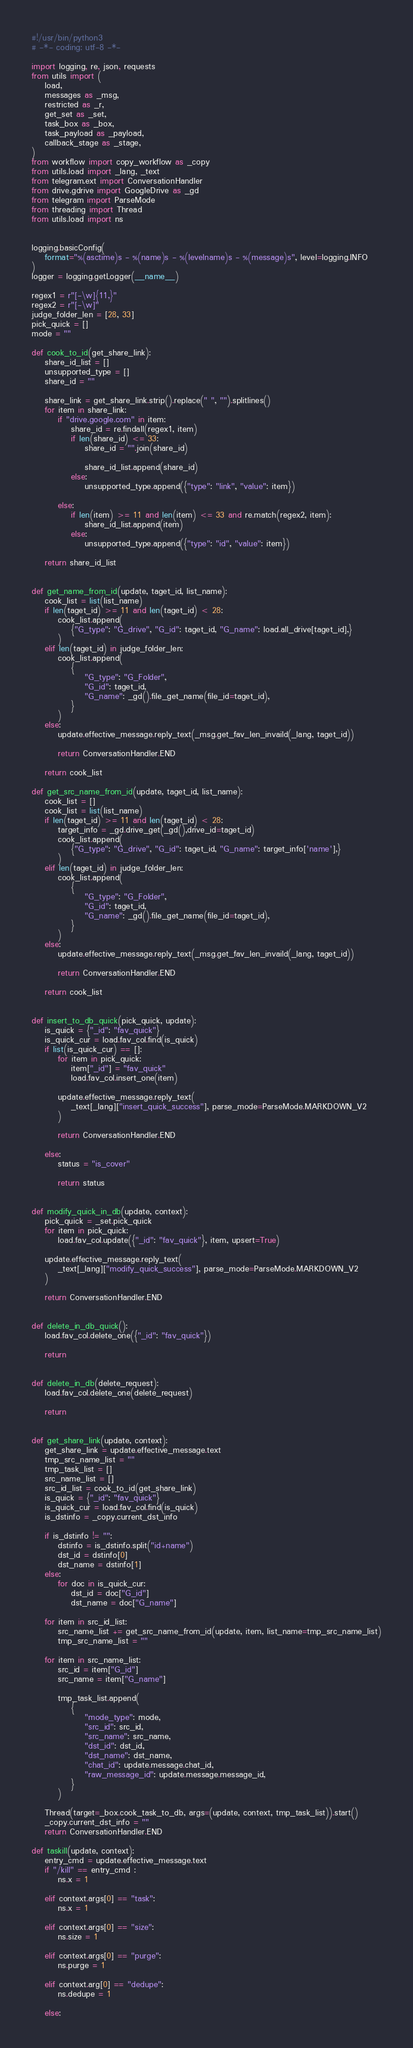Convert code to text. <code><loc_0><loc_0><loc_500><loc_500><_Python_>#!/usr/bin/python3
# -*- coding: utf-8 -*-

import logging, re, json, requests
from utils import (
    load,
    messages as _msg,
    restricted as _r,
    get_set as _set,
    task_box as _box,
    task_payload as _payload,
    callback_stage as _stage,
)
from workflow import copy_workflow as _copy
from utils.load import _lang, _text
from telegram.ext import ConversationHandler
from drive.gdrive import GoogleDrive as _gd
from telegram import ParseMode
from threading import Thread
from utils.load import ns


logging.basicConfig(
    format="%(asctime)s - %(name)s - %(levelname)s - %(message)s", level=logging.INFO
)
logger = logging.getLogger(__name__)

regex1 = r"[-\w]{11,}"
regex2 = r"[-\w]"
judge_folder_len = [28, 33]
pick_quick = []
mode = ""

def cook_to_id(get_share_link):
    share_id_list = []
    unsupported_type = []
    share_id = ""

    share_link = get_share_link.strip().replace(" ", "").splitlines()
    for item in share_link:
        if "drive.google.com" in item:
            share_id = re.findall(regex1, item)
            if len(share_id) <= 33:
                share_id = "".join(share_id)

                share_id_list.append(share_id)
            else:
                unsupported_type.append({"type": "link", "value": item})

        else:
            if len(item) >= 11 and len(item) <= 33 and re.match(regex2, item):
                share_id_list.append(item)
            else:
                unsupported_type.append({"type": "id", "value": item})

    return share_id_list


def get_name_from_id(update, taget_id, list_name):
    cook_list = list(list_name)
    if len(taget_id) >= 11 and len(taget_id) < 28:
        cook_list.append(
            {"G_type": "G_drive", "G_id": taget_id, "G_name": load.all_drive[taget_id],}
        )
    elif len(taget_id) in judge_folder_len:
        cook_list.append(
            {
                "G_type": "G_Folder",
                "G_id": taget_id,
                "G_name": _gd().file_get_name(file_id=taget_id),
            }
        )
    else:
        update.effective_message.reply_text(_msg.get_fav_len_invaild(_lang, taget_id))

        return ConversationHandler.END

    return cook_list

def get_src_name_from_id(update, taget_id, list_name):
    cook_list = []
    cook_list = list(list_name)
    if len(taget_id) >= 11 and len(taget_id) < 28:
        target_info = _gd.drive_get(_gd(),drive_id=taget_id)
        cook_list.append(
            {"G_type": "G_drive", "G_id": taget_id, "G_name": target_info['name'],}
        )
    elif len(taget_id) in judge_folder_len:
        cook_list.append(
            {
                "G_type": "G_Folder",
                "G_id": taget_id,
                "G_name": _gd().file_get_name(file_id=taget_id),
            }
        )
    else:
        update.effective_message.reply_text(_msg.get_fav_len_invaild(_lang, taget_id))

        return ConversationHandler.END

    return cook_list


def insert_to_db_quick(pick_quick, update):
    is_quick = {"_id": "fav_quick"}
    is_quick_cur = load.fav_col.find(is_quick)
    if list(is_quick_cur) == []:
        for item in pick_quick:
            item["_id"] = "fav_quick"
            load.fav_col.insert_one(item)

        update.effective_message.reply_text(
            _text[_lang]["insert_quick_success"], parse_mode=ParseMode.MARKDOWN_V2
        )

        return ConversationHandler.END

    else:
        status = "is_cover"

        return status


def modify_quick_in_db(update, context):
    pick_quick = _set.pick_quick
    for item in pick_quick:
        load.fav_col.update({"_id": "fav_quick"}, item, upsert=True)

    update.effective_message.reply_text(
        _text[_lang]["modify_quick_success"], parse_mode=ParseMode.MARKDOWN_V2
    )

    return ConversationHandler.END


def delete_in_db_quick():
    load.fav_col.delete_one({"_id": "fav_quick"})

    return


def delete_in_db(delete_request):
    load.fav_col.delete_one(delete_request)

    return


def get_share_link(update, context):
    get_share_link = update.effective_message.text
    tmp_src_name_list = ""
    tmp_task_list = []
    src_name_list = []
    src_id_list = cook_to_id(get_share_link)
    is_quick = {"_id": "fav_quick"}
    is_quick_cur = load.fav_col.find(is_quick)
    is_dstinfo = _copy.current_dst_info

    if is_dstinfo != "":
        dstinfo = is_dstinfo.split("id+name")
        dst_id = dstinfo[0]
        dst_name = dstinfo[1]
    else:
        for doc in is_quick_cur:
            dst_id = doc["G_id"]
            dst_name = doc["G_name"]

    for item in src_id_list:
        src_name_list += get_src_name_from_id(update, item, list_name=tmp_src_name_list)
        tmp_src_name_list = ""

    for item in src_name_list:
        src_id = item["G_id"]
        src_name = item["G_name"]

        tmp_task_list.append(
            {
                "mode_type": mode,
                "src_id": src_id,
                "src_name": src_name,
                "dst_id": dst_id,
                "dst_name": dst_name,
                "chat_id": update.message.chat_id,
                "raw_message_id": update.message.message_id,
            }
        )

    Thread(target=_box.cook_task_to_db, args=(update, context, tmp_task_list)).start()
    _copy.current_dst_info = ""
    return ConversationHandler.END

def taskill(update, context):
    entry_cmd = update.effective_message.text
    if "/kill" == entry_cmd :
        ns.x = 1
    
    elif context.args[0] == "task":
        ns.x = 1

    elif context.args[0] == "size":
        ns.size = 1    

    elif context.args[0] == "purge":
        ns.purge = 1

    elif context.arg[0] == "dedupe":
        ns.dedupe = 1

    else:</code> 